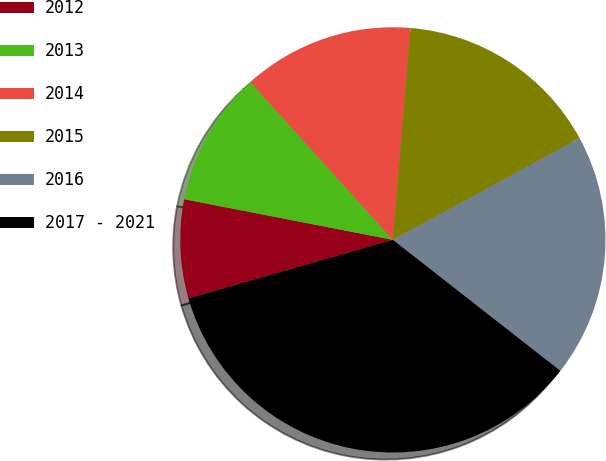Convert chart. <chart><loc_0><loc_0><loc_500><loc_500><pie_chart><fcel>2012<fcel>2013<fcel>2014<fcel>2015<fcel>2016<fcel>2017 - 2021<nl><fcel>7.5%<fcel>10.25%<fcel>13.0%<fcel>15.75%<fcel>18.5%<fcel>35.0%<nl></chart> 